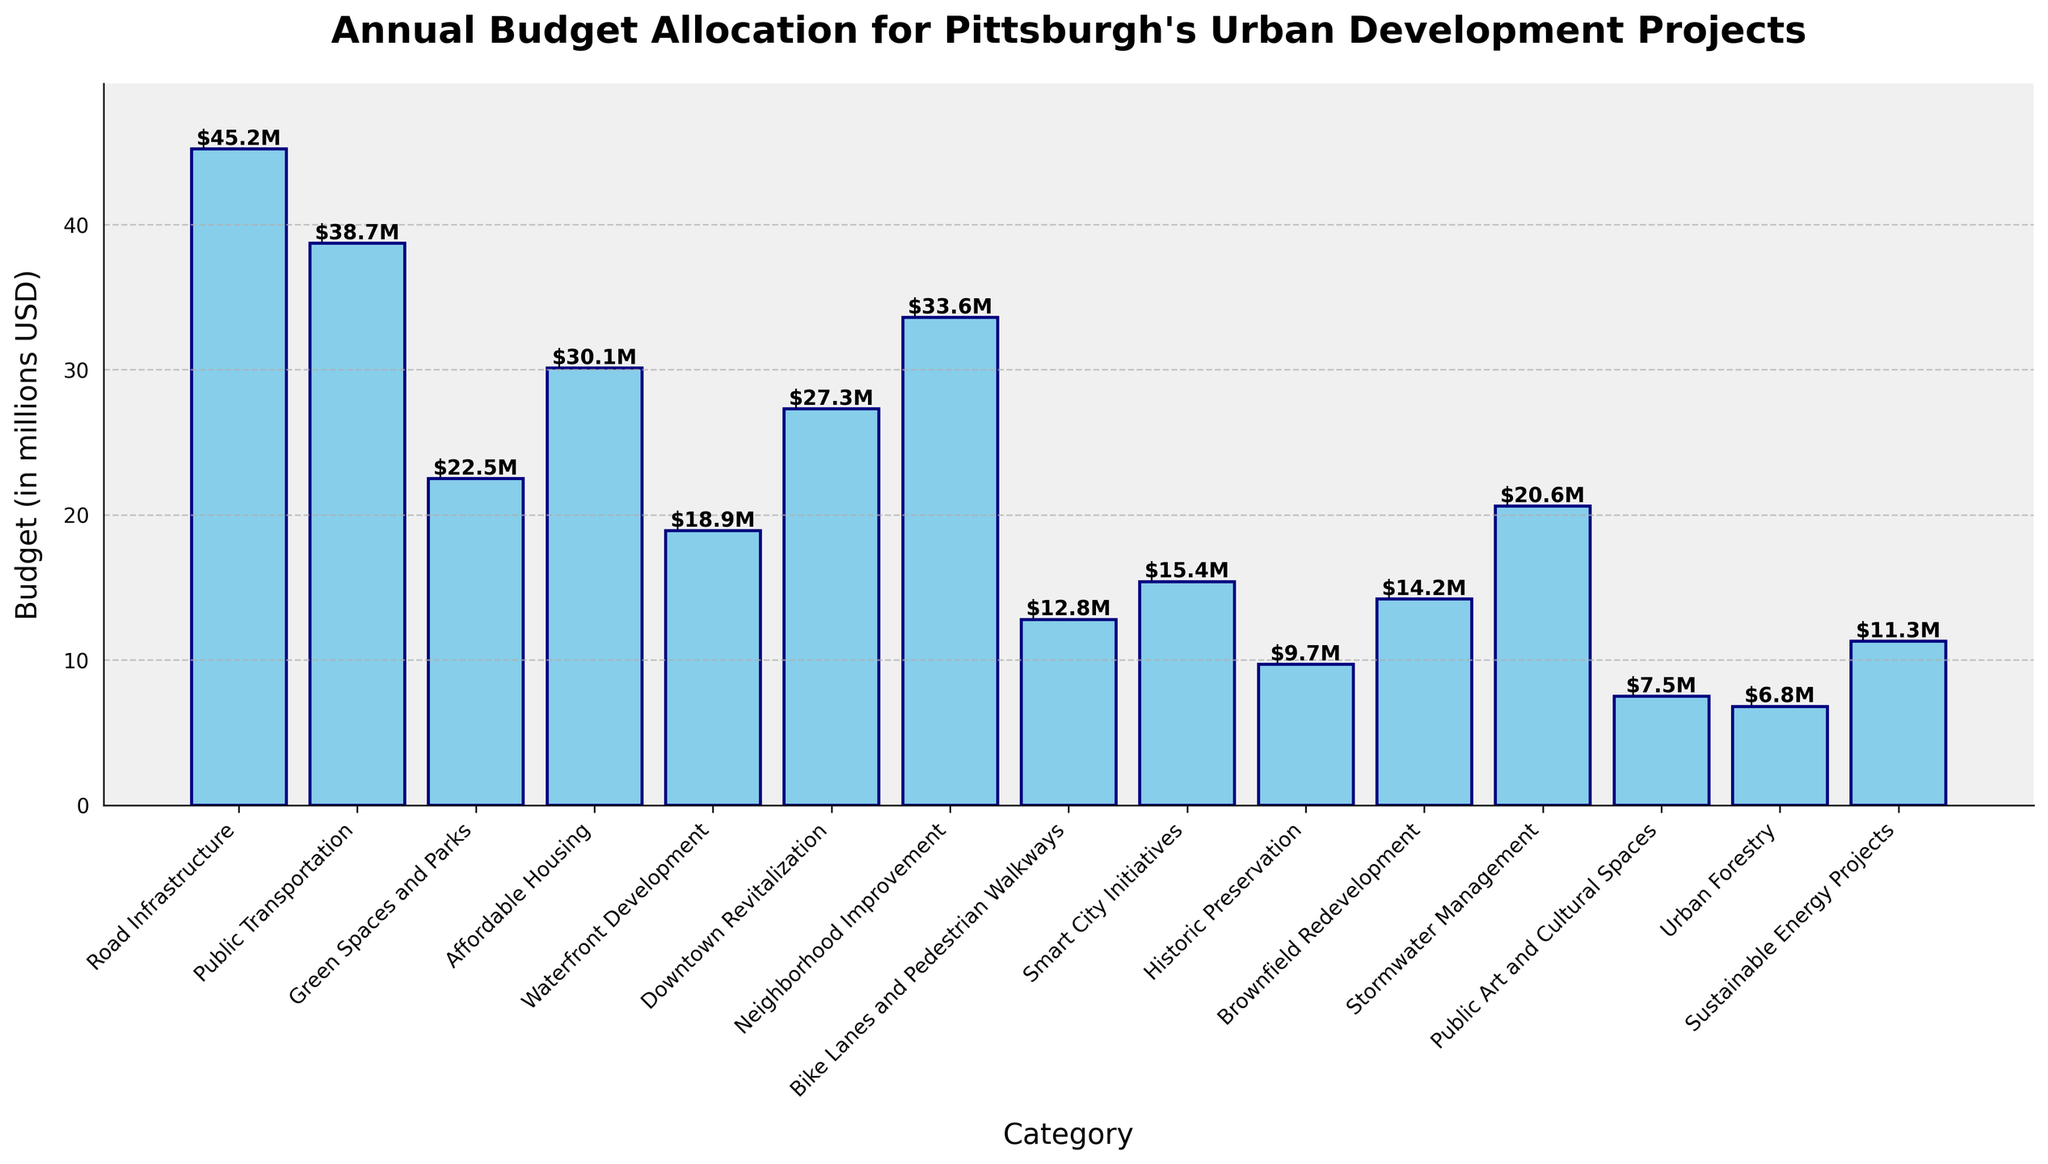Which category has the highest budget allocation? By examining the height of each bar, the "Road Infrastructure" category clearly has the highest bar, indicating the largest budget allocation.
Answer: Road Infrastructure What is the total budget for "Green Spaces and Parks" and "Waterfront Development"? Add "Green Spaces and Parks" budget (22.5M) and "Waterfront Development" budget (18.9M). 22.5 + 18.9 = 41.4
Answer: 41.4 million USD Is the budget for "Affordable Housing" higher than "Neighborhood Improvement"? Compare the heights of the bars for "Affordable Housing" (30.1M) and "Neighborhood Improvement" (33.6M). The bar for "Neighborhood Improvement" is higher.
Answer: No Which category has the smallest budget allocation? By looking at the shortest bar in the chart, "Urban Forestry" has the smallest budget allocation (6.8M).
Answer: Urban Forestry What is the difference in budget allocation between "Public Transportation" and "Bike Lanes and Pedestrian Walkways"? Subtract the budget for "Bike Lanes and Pedestrian Walkways" (12.8M) from "Public Transportation" (38.7M). 38.7 - 12.8 = 25.9
Answer: 25.9 million USD How many categories have a budget allocation greater than 30 million USD? Count the number of bars with heights representing values greater than 30M. They are "Road Infrastructure" (45.2M) and "Neighborhood Improvement" (33.6M) - a total of 2 categories.
Answer: 2 What is the combined budget allocation for "Stormwater Management," "Public Art and Cultural Spaces," and "Sustainable Energy Projects"? Add the budgets of "Stormwater Management" (20.6M), "Public Art and Cultural Spaces" (7.5M), and "Sustainable Energy Projects" (11.3M). 20.6 + 7.5 + 11.3 = 39.4
Answer: 39.4 million USD Which categories have a higher budget allocation than "Downtown Revitalization"? Compare budgets by checking the heights of the bars. The bars higher than "Downtown Revitalization" (27.3M) are "Road Infrastructure" (45.2M), "Public Transportation" (38.7M), "Affordable Housing" (30.1M), and "Neighborhood Improvement" (33.6M).
Answer: Road Infrastructure, Public Transportation, Affordable Housing, Neighborhood Improvement What is the average budget allocation across all categories? Sum all budget allocations: 45.2 + 38.7 + 22.5 + 30.1 + 18.9 + 27.3 + 33.6 + 12.8 + 15.4 + 9.7 + 14.2 + 20.6 + 7.5 + 6.8 + 11.3 = 314.6. Then divide by the number of categories (15). 314.6 / 15 = 21.0
Answer: 21.0 million USD 